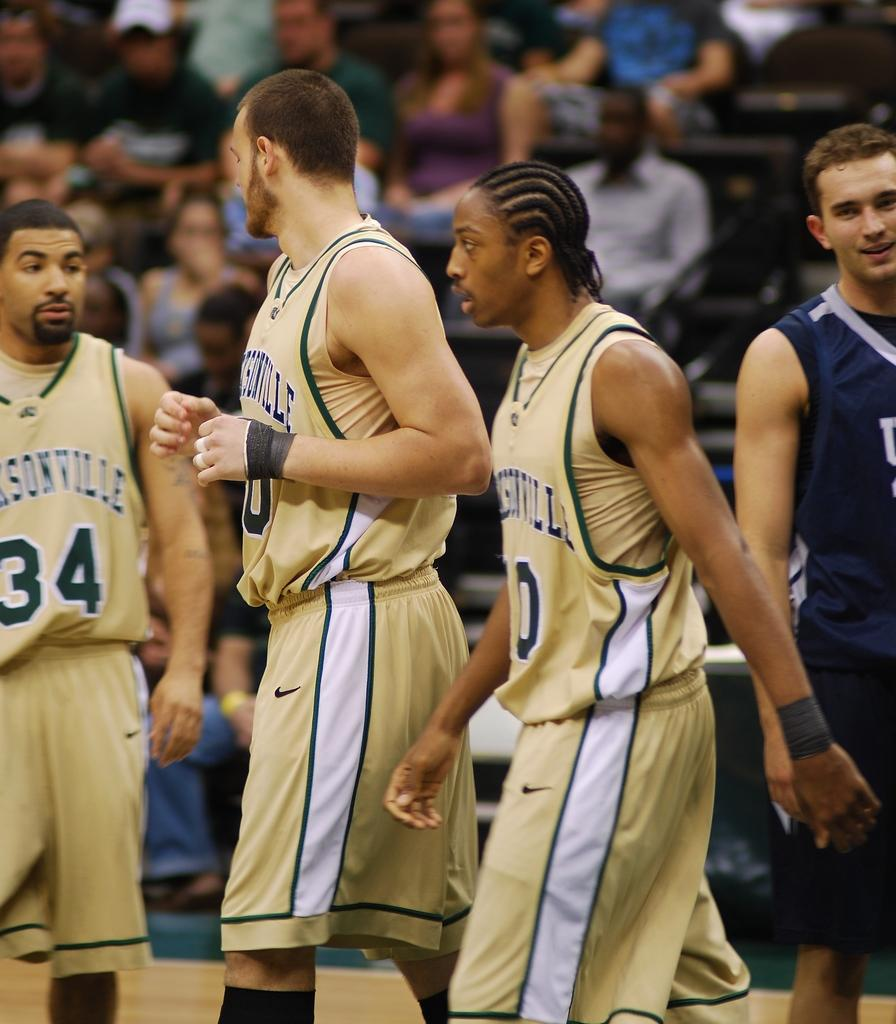<image>
Create a compact narrative representing the image presented. 3 Jacksonville basketball players are walking on the court. 